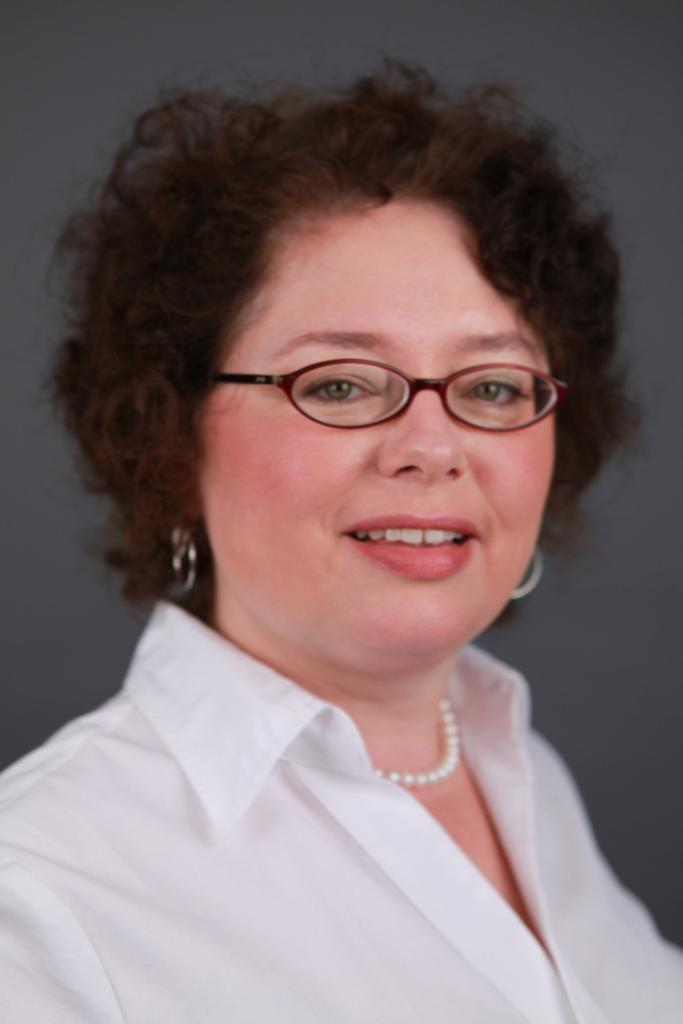Who is present in the image? There is a woman in the image. What is the woman's facial expression? The woman is smiling. What accessories is the woman wearing? The woman is wearing spectacles, earrings, and a necklace. Can you describe the background of the image? The background of the image is blurry. What type of sweater is the woman wearing in the image? There is no sweater visible in the image; the woman is not wearing one. What is the woman's reaction to the shocking event in the image? There is no shocking event or reaction present in the image; the woman is simply smiling. 